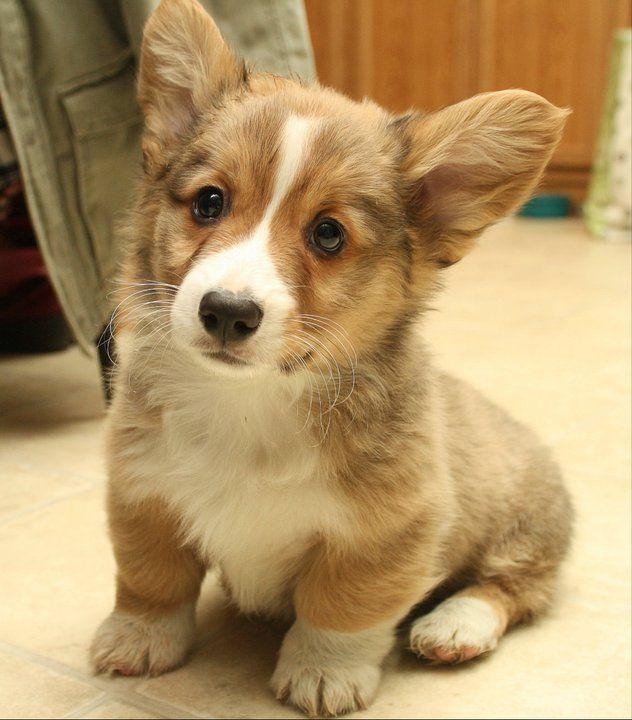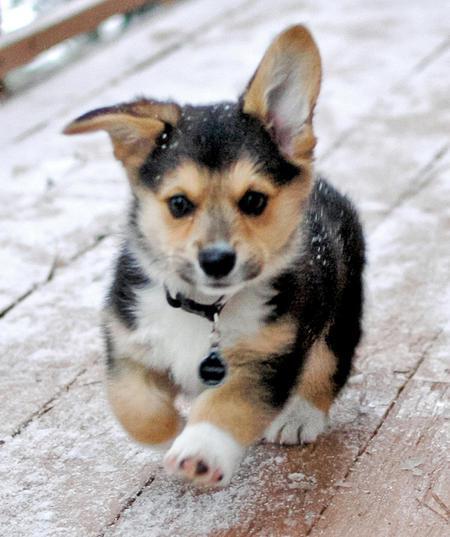The first image is the image on the left, the second image is the image on the right. For the images displayed, is the sentence "The dog in the left image is standing on all four legs with its body pointing left." factually correct? Answer yes or no. No. The first image is the image on the left, the second image is the image on the right. Assess this claim about the two images: "The image on the right shows a corgi puppy in movement and the left one shows a corgi puppy sitting down.". Correct or not? Answer yes or no. Yes. 